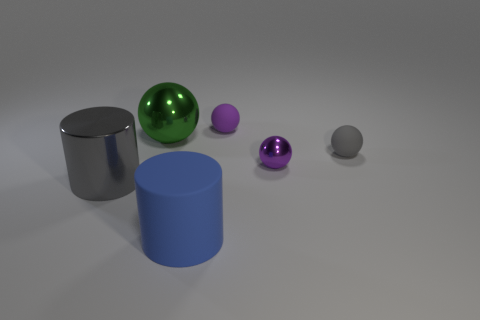Is there a sphere of the same color as the tiny metallic thing?
Your answer should be very brief. Yes. What material is the tiny thing that is the same color as the tiny shiny ball?
Offer a terse response. Rubber. The other shiny thing that is the same shape as the big blue object is what size?
Ensure brevity in your answer.  Large. What shape is the large blue rubber object?
Your response must be concise. Cylinder. There is a shiny thing that is the same size as the gray rubber ball; what is its shape?
Offer a terse response. Sphere. Is there any other thing that is the same color as the large rubber thing?
Offer a terse response. No. What is the size of the purple thing that is the same material as the gray cylinder?
Make the answer very short. Small. There is a purple rubber thing; is it the same shape as the shiny object on the right side of the large blue cylinder?
Offer a very short reply. Yes. How big is the purple shiny sphere?
Provide a succinct answer. Small. Is the number of big metal spheres that are right of the purple rubber ball less than the number of blue things?
Your answer should be compact. Yes. 